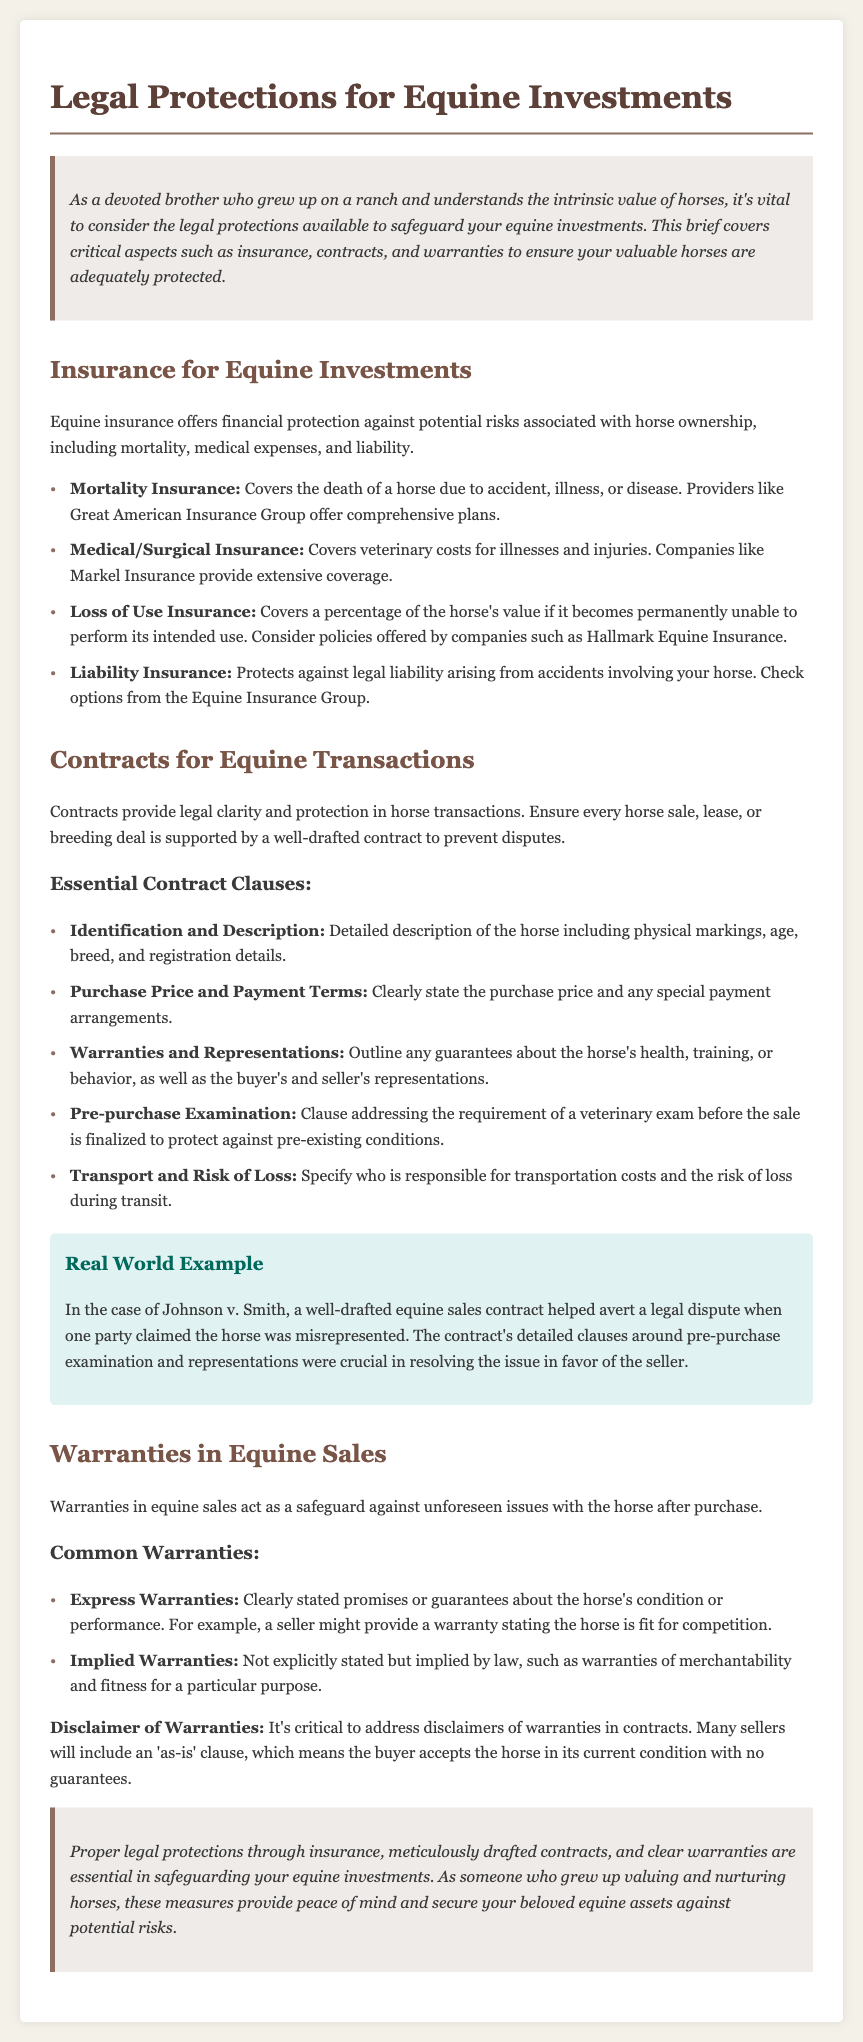What is the main topic of the brief? The main topic is the legal protections available for equine investments.
Answer: Legal Protections for Equine Investments Which insurance covers the death of a horse? This insurance type specifically provides coverage for the death of a horse due to various reasons.
Answer: Mortality Insurance What is one key element that should be included in a horse sale contract? This element provides clarity regarding the horse's specific details to protect all parties involved.
Answer: Identification and Description What type of warranty is based on law rather than explicit statements? This type of warranty may not be directly stated but is covered by legal implications.
Answer: Implied Warranties What is the purpose of 'as-is' clauses in contracts? These clauses clarify how the buyer accepts the horse, affecting future claims related to condition.
Answer: Disclaimer of Warranties 